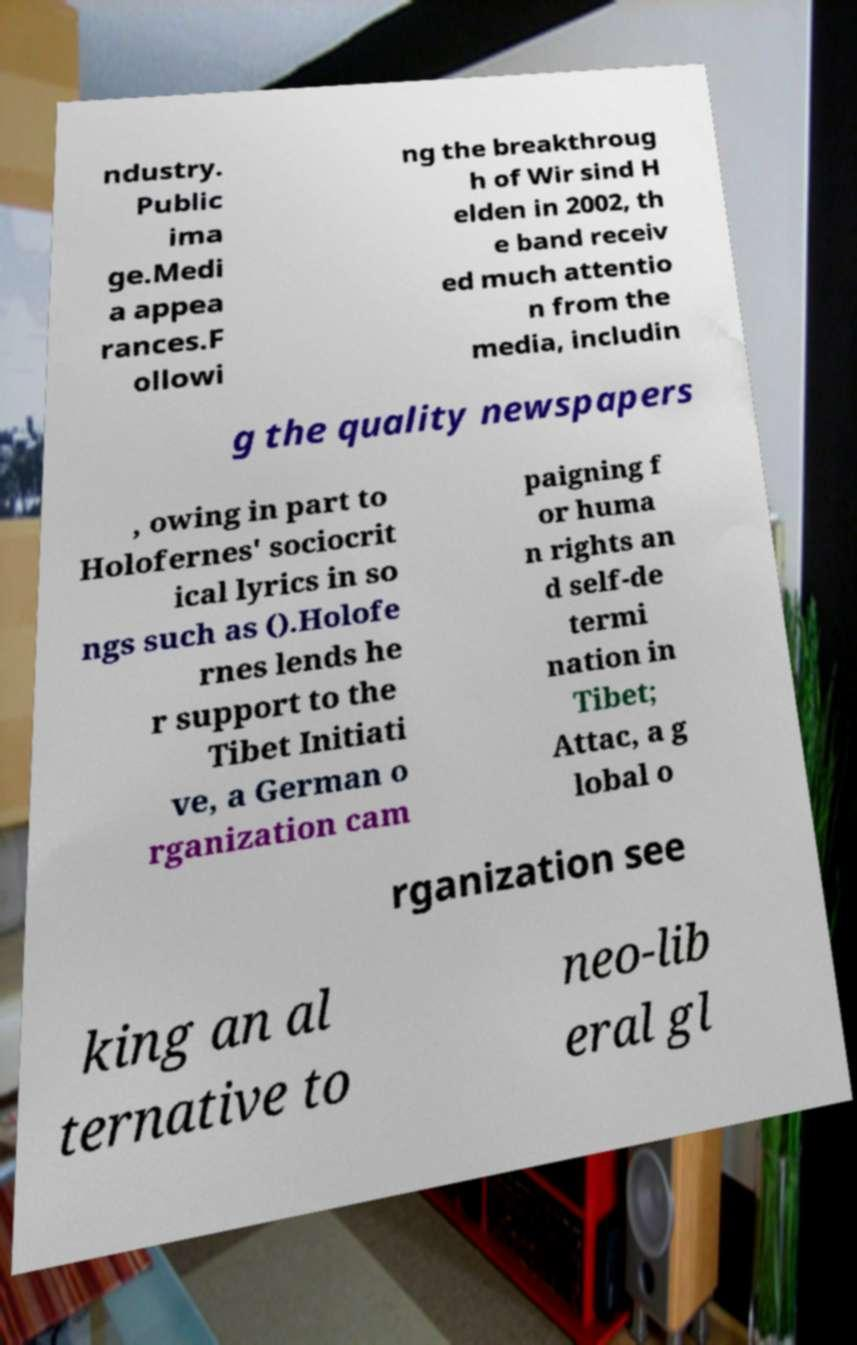Please read and relay the text visible in this image. What does it say? ndustry. Public ima ge.Medi a appea rances.F ollowi ng the breakthroug h of Wir sind H elden in 2002, th e band receiv ed much attentio n from the media, includin g the quality newspapers , owing in part to Holofernes' sociocrit ical lyrics in so ngs such as ().Holofe rnes lends he r support to the Tibet Initiati ve, a German o rganization cam paigning f or huma n rights an d self-de termi nation in Tibet; Attac, a g lobal o rganization see king an al ternative to neo-lib eral gl 